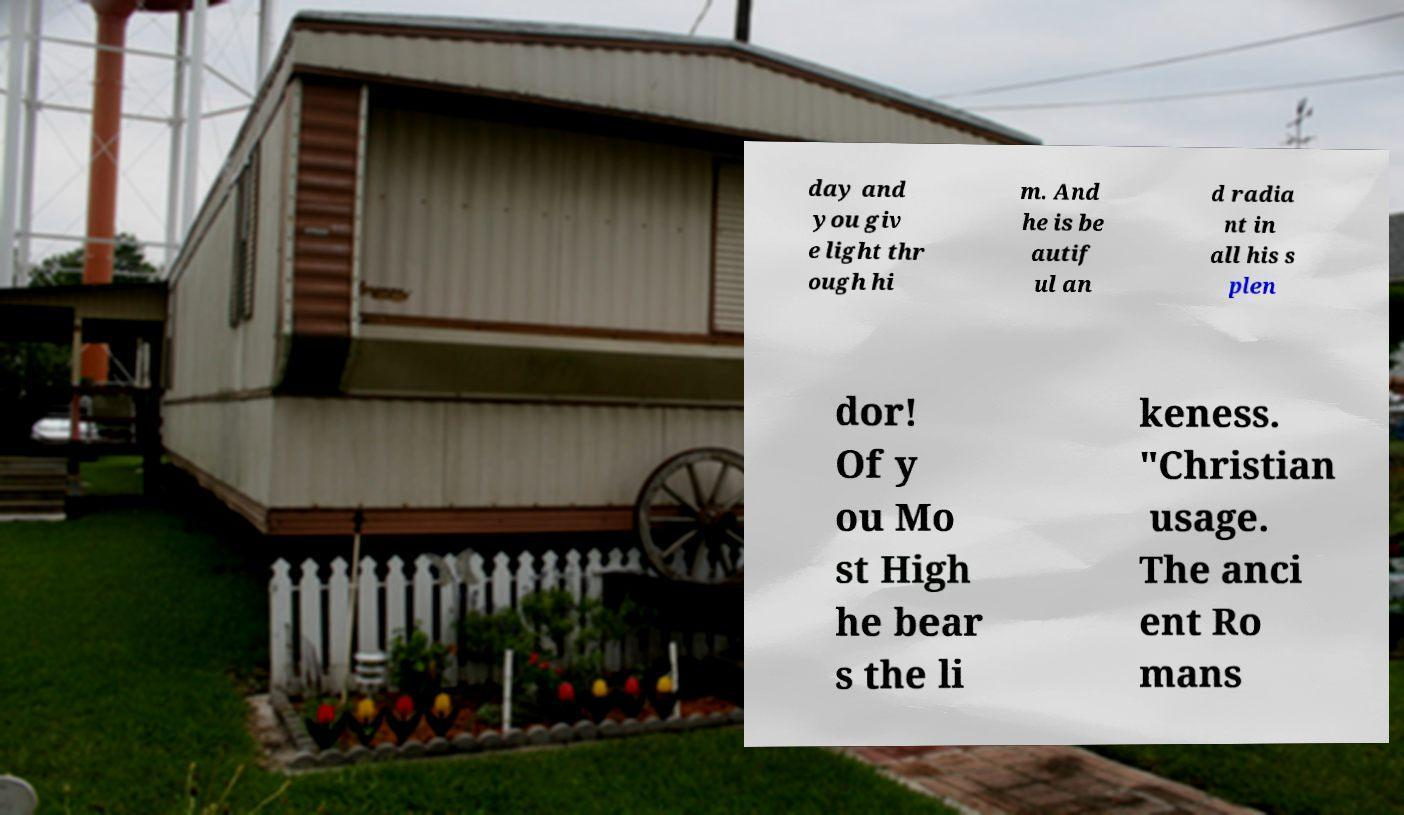Could you assist in decoding the text presented in this image and type it out clearly? day and you giv e light thr ough hi m. And he is be autif ul an d radia nt in all his s plen dor! Of y ou Mo st High he bear s the li keness. "Christian usage. The anci ent Ro mans 